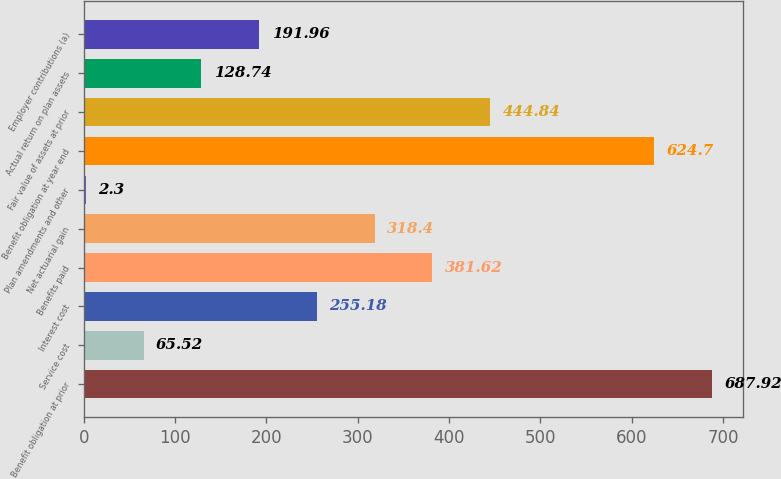<chart> <loc_0><loc_0><loc_500><loc_500><bar_chart><fcel>Benefit obligation at prior<fcel>Service cost<fcel>Interest cost<fcel>Benefits paid<fcel>Net actuarial gain<fcel>Plan amendments and other<fcel>Benefit obligation at year end<fcel>Fair value of assets at prior<fcel>Actual return on plan assets<fcel>Employer contributions (a)<nl><fcel>687.92<fcel>65.52<fcel>255.18<fcel>381.62<fcel>318.4<fcel>2.3<fcel>624.7<fcel>444.84<fcel>128.74<fcel>191.96<nl></chart> 